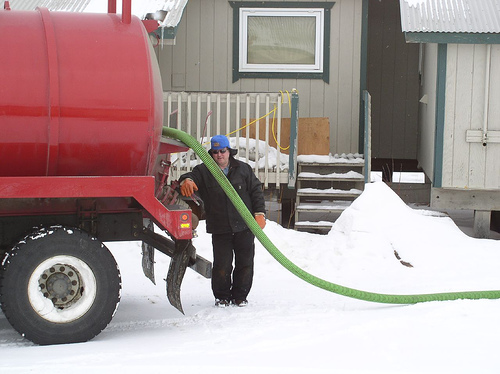<image>
Is the truck to the left of the house? Yes. From this viewpoint, the truck is positioned to the left side relative to the house. Is the man behind the hose? Yes. From this viewpoint, the man is positioned behind the hose, with the hose partially or fully occluding the man. 